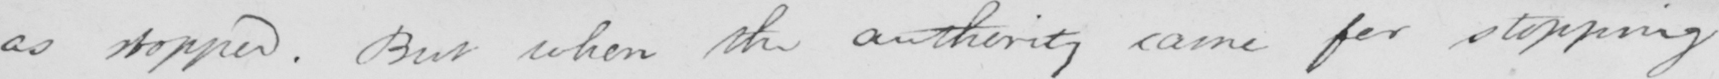What does this handwritten line say? as stopped . But when the authority came for stopping 